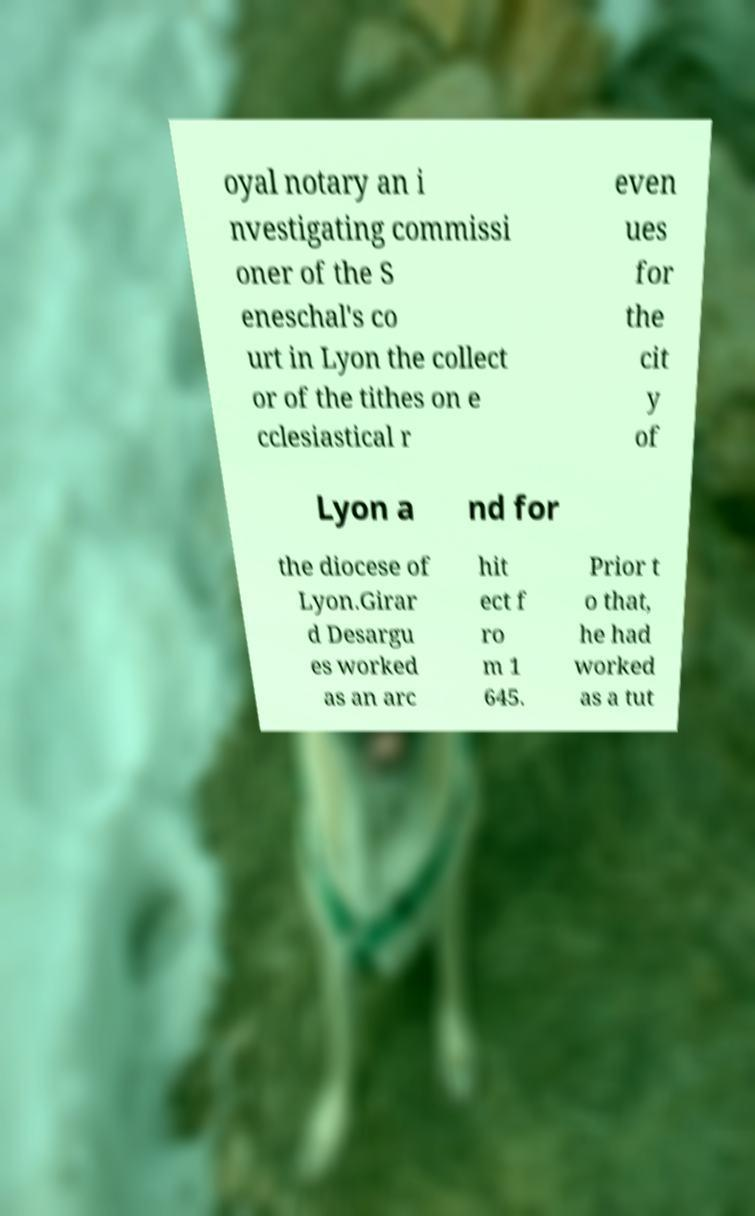Could you assist in decoding the text presented in this image and type it out clearly? oyal notary an i nvestigating commissi oner of the S eneschal's co urt in Lyon the collect or of the tithes on e cclesiastical r even ues for the cit y of Lyon a nd for the diocese of Lyon.Girar d Desargu es worked as an arc hit ect f ro m 1 645. Prior t o that, he had worked as a tut 